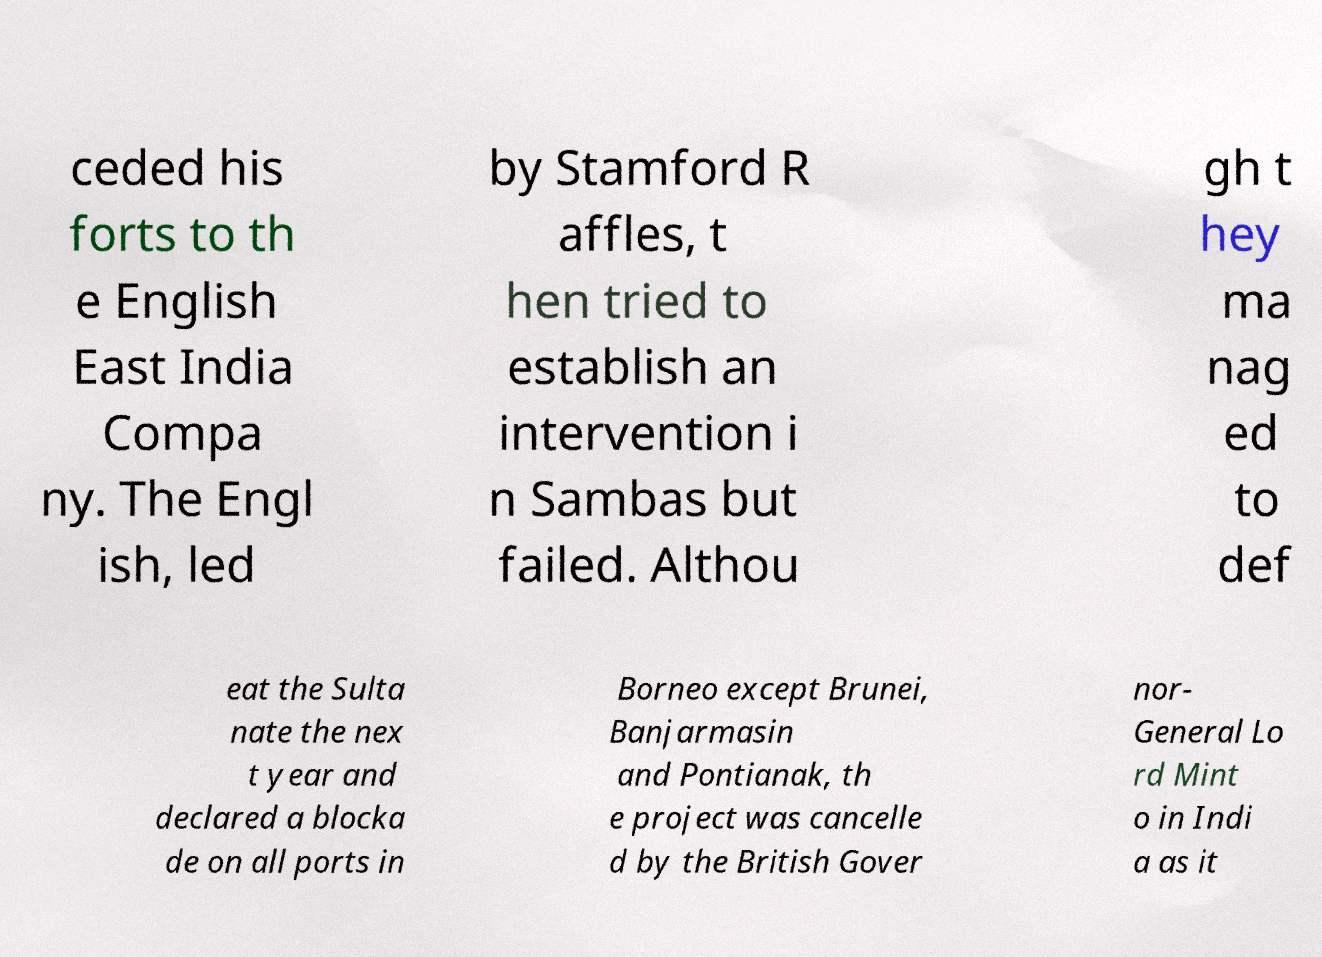Can you read and provide the text displayed in the image?This photo seems to have some interesting text. Can you extract and type it out for me? ceded his forts to th e English East India Compa ny. The Engl ish, led by Stamford R affles, t hen tried to establish an intervention i n Sambas but failed. Althou gh t hey ma nag ed to def eat the Sulta nate the nex t year and declared a blocka de on all ports in Borneo except Brunei, Banjarmasin and Pontianak, th e project was cancelle d by the British Gover nor- General Lo rd Mint o in Indi a as it 